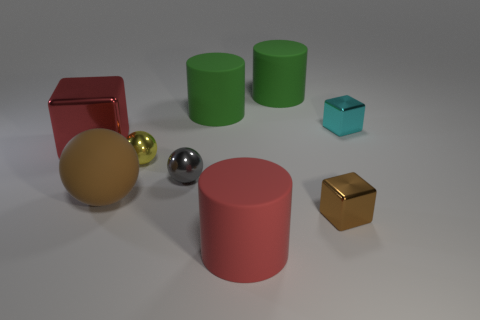What is the material of the cyan cube that is the same size as the yellow sphere?
Your answer should be compact. Metal. Is there a tiny metallic object that has the same color as the large metal block?
Ensure brevity in your answer.  No. What shape is the small metal thing that is in front of the yellow shiny object and behind the large ball?
Provide a short and direct response. Sphere. How many big brown objects are made of the same material as the gray object?
Ensure brevity in your answer.  0. Is the number of large green things that are on the right side of the cyan shiny object less than the number of tiny metallic blocks behind the large red shiny cube?
Offer a very short reply. Yes. There is a red object in front of the metal cube left of the big red object that is in front of the matte ball; what is it made of?
Provide a short and direct response. Rubber. There is a rubber object that is to the left of the large red rubber object and in front of the big metallic cube; what is its size?
Make the answer very short. Large. How many cylinders are big brown rubber things or cyan matte objects?
Keep it short and to the point. 0. The ball that is the same size as the gray metal thing is what color?
Your answer should be compact. Yellow. Is there any other thing that has the same shape as the large red shiny thing?
Provide a short and direct response. Yes. 